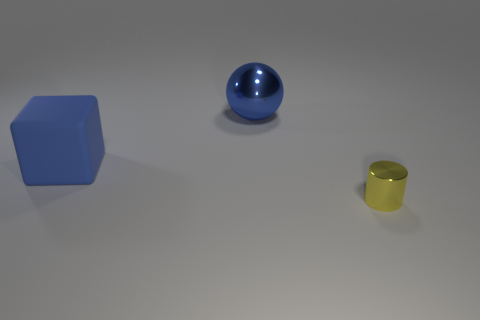Add 3 small gray metal blocks. How many objects exist? 6 Subtract all spheres. How many objects are left? 2 Subtract all small blue cylinders. Subtract all large blue things. How many objects are left? 1 Add 2 matte objects. How many matte objects are left? 3 Add 3 large blue spheres. How many large blue spheres exist? 4 Subtract 0 green cubes. How many objects are left? 3 